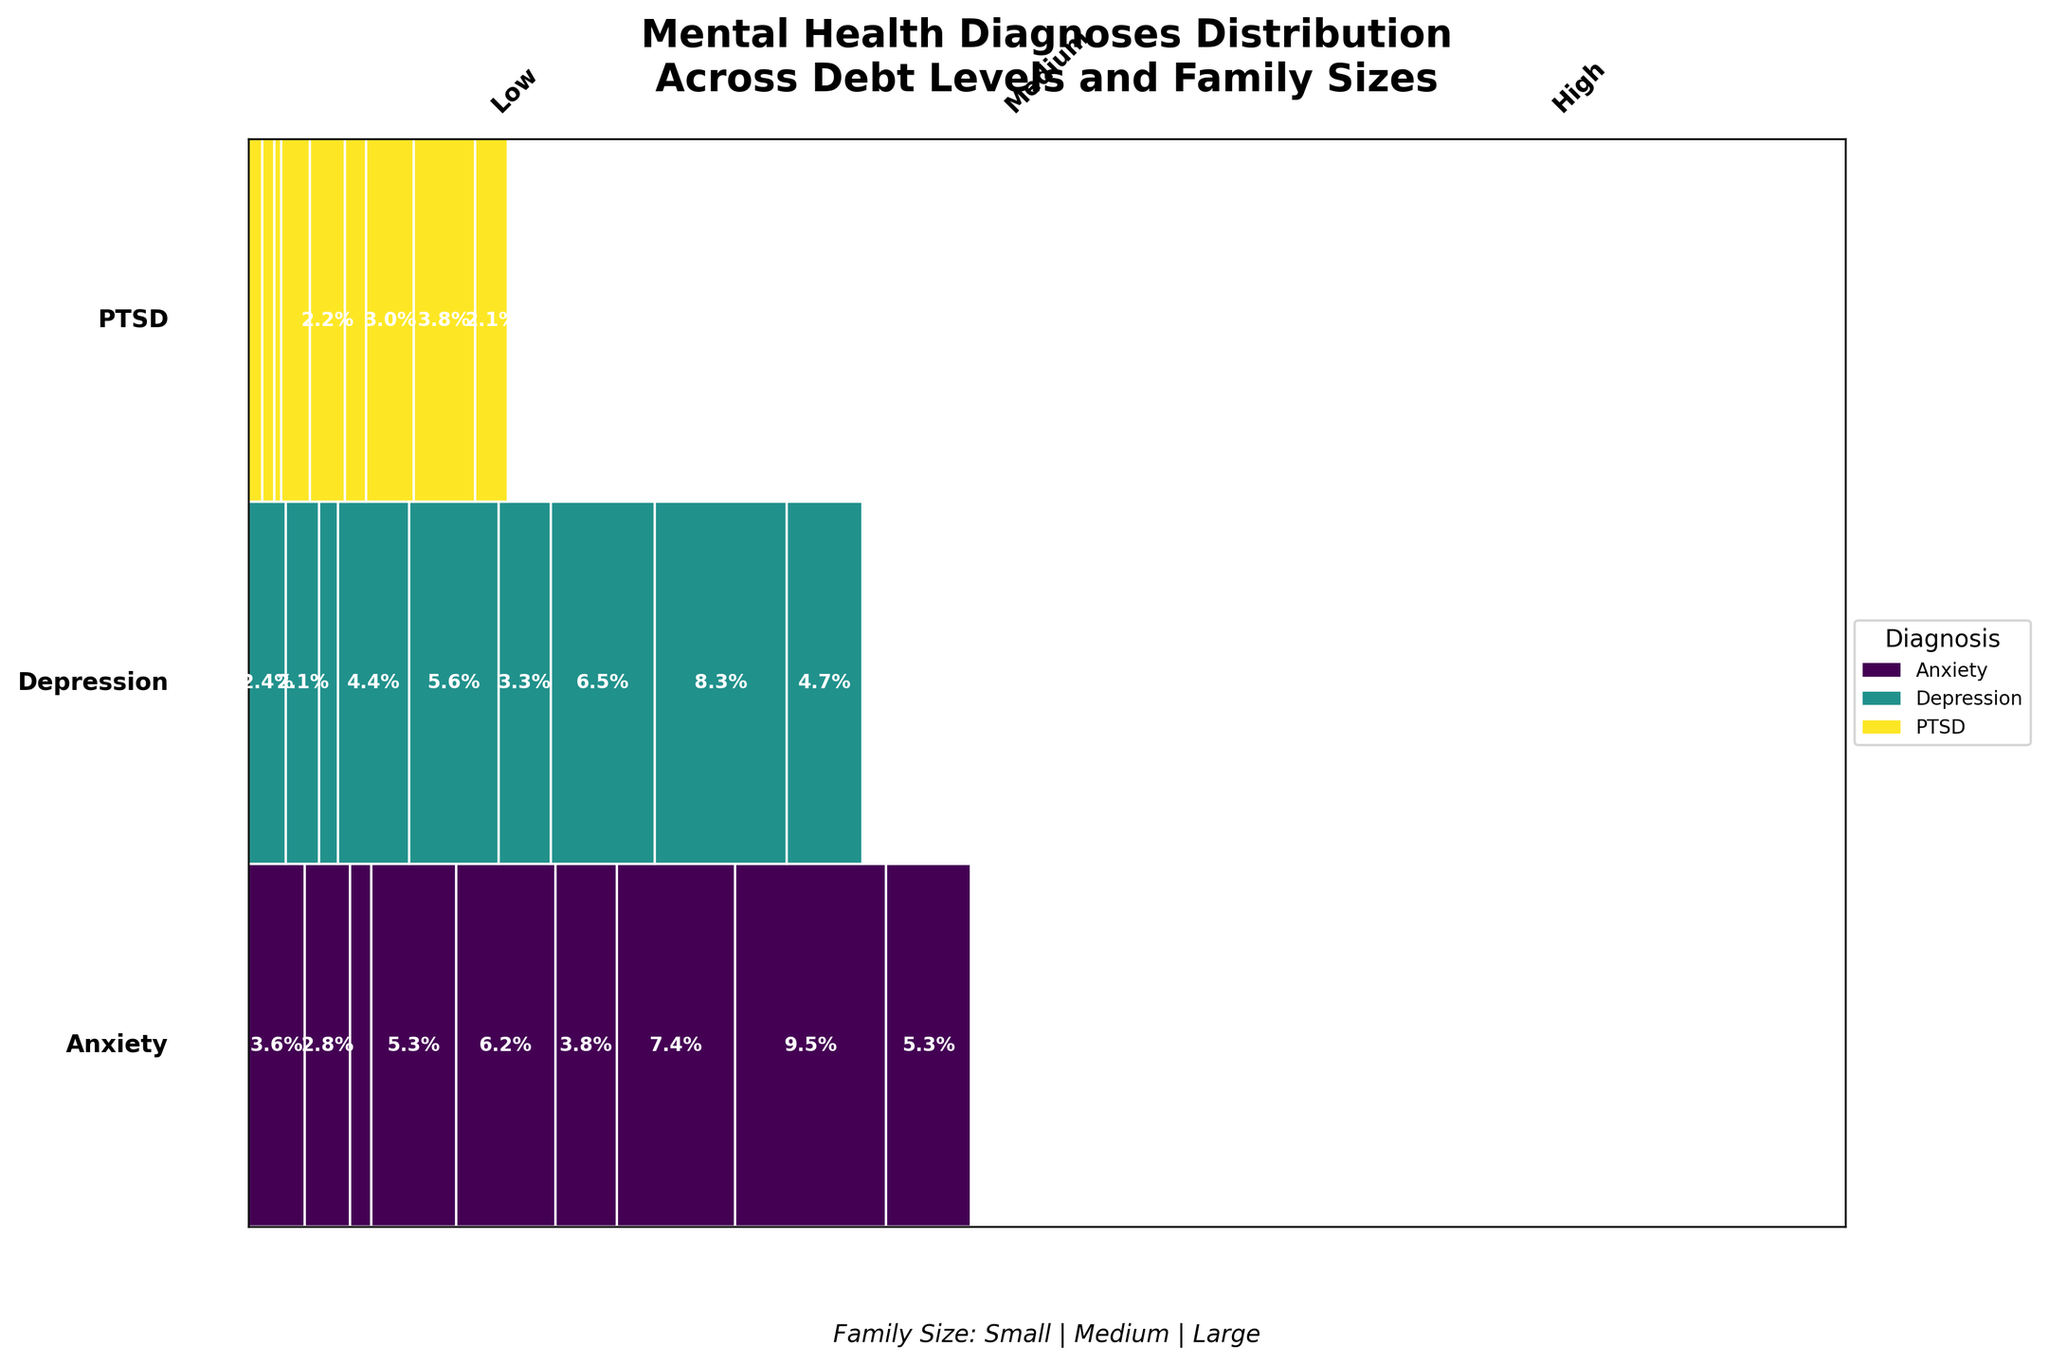How are the different debt levels represented in the plot visually? The different debt levels are represented along a horizontal axis with divisions, where each section is labeled for 'Low,' 'Medium,' and 'High.'
Answer: Horizontal sections labeled 'Low,' 'Medium,' 'High' What is the general trend in mental health diagnoses as debt levels increase? As debt levels increase from 'Low' to 'High,' the percentage areas for Anxiety, Depression, and PTSD typically increase. This is indicated by larger rectangles in the 'High' debt level compared to 'Low' and 'Medium' levels within each family size category.
Answer: Increase in percentage areas for Anxiety, Depression, and PTSD Which mental health diagnosis has the highest representation among families with a 'High' level of debt and small family size? To find the mental health diagnosis with the highest representation, look at the 'High' debt level section for 'Small' family size and identify the largest area. Anxiety has the largest area in this category.
Answer: Anxiety Which family size appears to have the highest representation for Depression under 'High' debt levels? Observe the 'High' debt level, then check the distribution of Depression across 'Small,' 'Medium,' and 'Large' family sizes. Depression has the largest area in the 'Medium' family size under 'High' debt levels.
Answer: Medium Compare the proportion of PTSD in 'Medium' debt levels for small and large family sizes. Which one is larger? Locate the 'Medium' debt level and compare the areas representing PTSD. For 'Small' and 'Large' family sizes, PTSD has a larger area in the 'Small' family size compared to the 'Large' family size.
Answer: Small What mental health diagnosis has a modest but visible presence across all debt levels and family sizes? All diagnoses are observed across varied debt levels and family sizes. PTSD, while smaller in overall representation, is consistently present across all categories.
Answer: PTSD What proportion of Anxiety cases can be found within the 'High' debt level and 'Medium' family size? Identify the 'High' debt level category and find the 'Medium' family size. The rectangle labeled with a percentage within this area represents the proportion, approximately shown as 32.0%.
Answer: ~32.0% How does the representation of Depression change from low to high debt levels in medium-sized families? Look at the rectangles for 'Medium' family sizes across 'Low,' 'Medium,' and 'High' debt levels under Depression. There is a visible increase in the area from 'Low' to 'High,' indicating a higher proportion as debt level increases.
Answer: Increase Which family size under 'Low' debt levels shows the least representation for any mental health diagnosis? Identify the smallest area in rectangles within 'Low' debt levels across all family sizes. PTSD in 'Large' family size in the 'Low' debt level has the smallest area.
Answer: PTSD, Large family size 